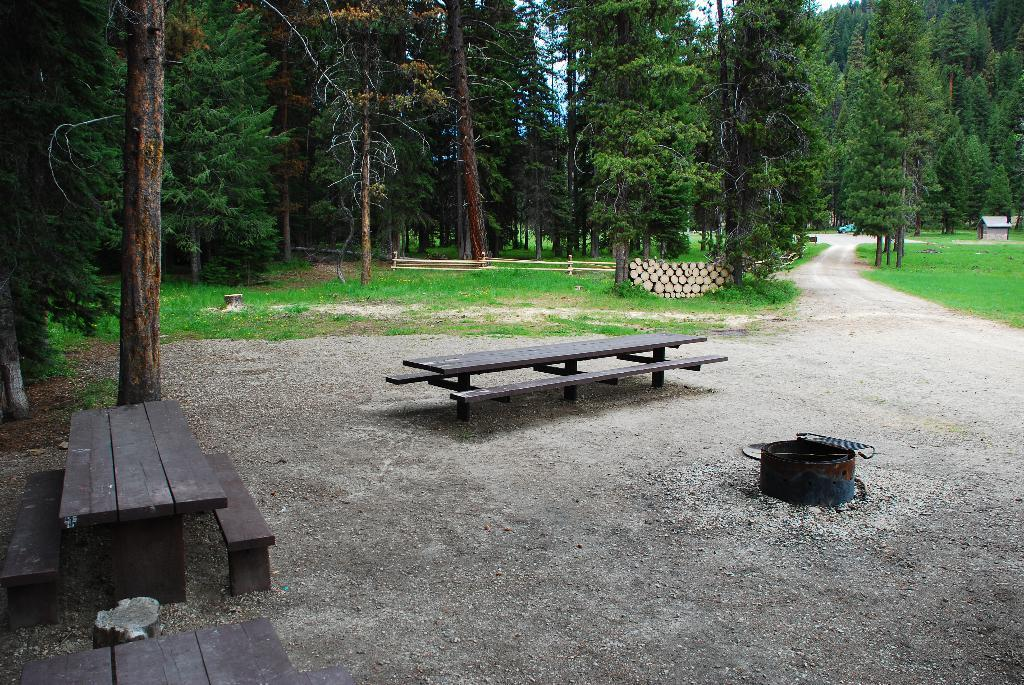What type of seating is visible in the foreground of the image? There are wooden benches in the foreground of the image. What can be seen on the right side of the image? There is an object on the right side of the image. What type of natural environment is visible in the background of the image? There are trees and grassland in the background of the image. What architectural features can be seen in the background of the image? There is a railing, a house, and a vehicle in the background of the image. What is visible in the sky in the background of the image? The sky is visible in the background of the image. How many knots are tied in the grassland in the image? There are no knots present in the grassland in the image. What type of mist can be seen surrounding the trees in the image? There is no mist present in the image; the trees are visible in the background. 